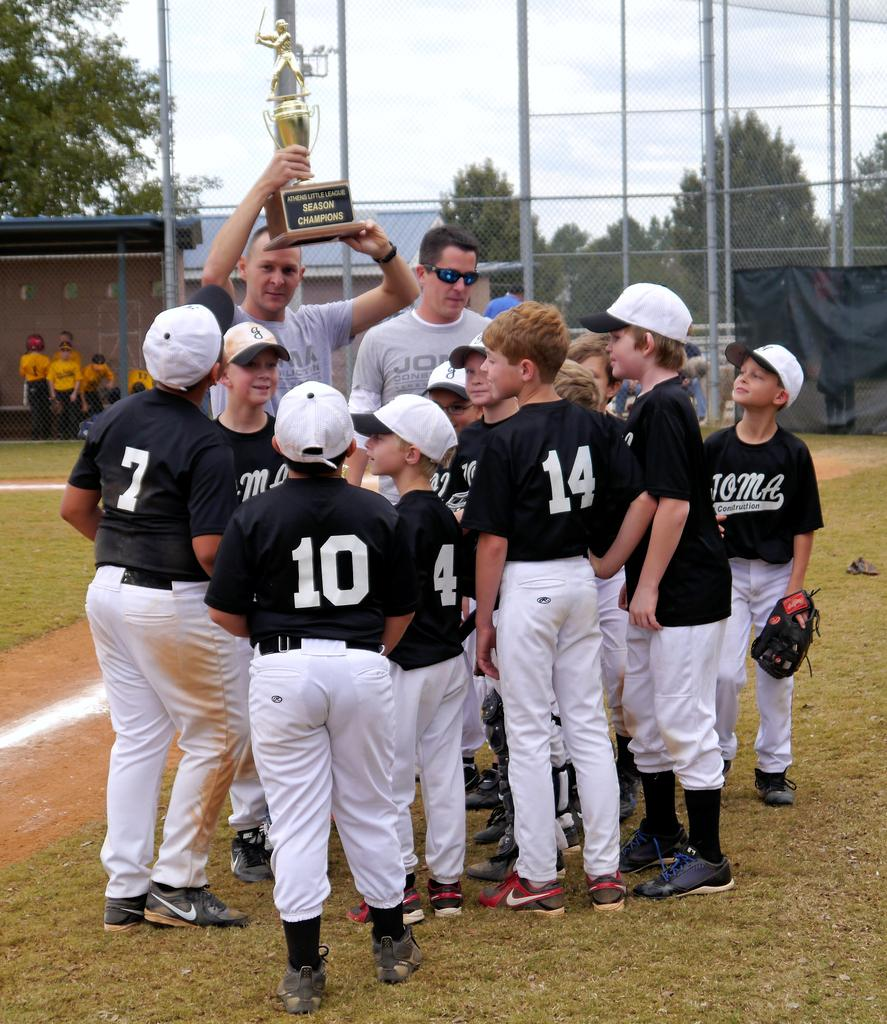Provide a one-sentence caption for the provided image. A group of little league baseball players circled up with their coaches hold up a trophy. 